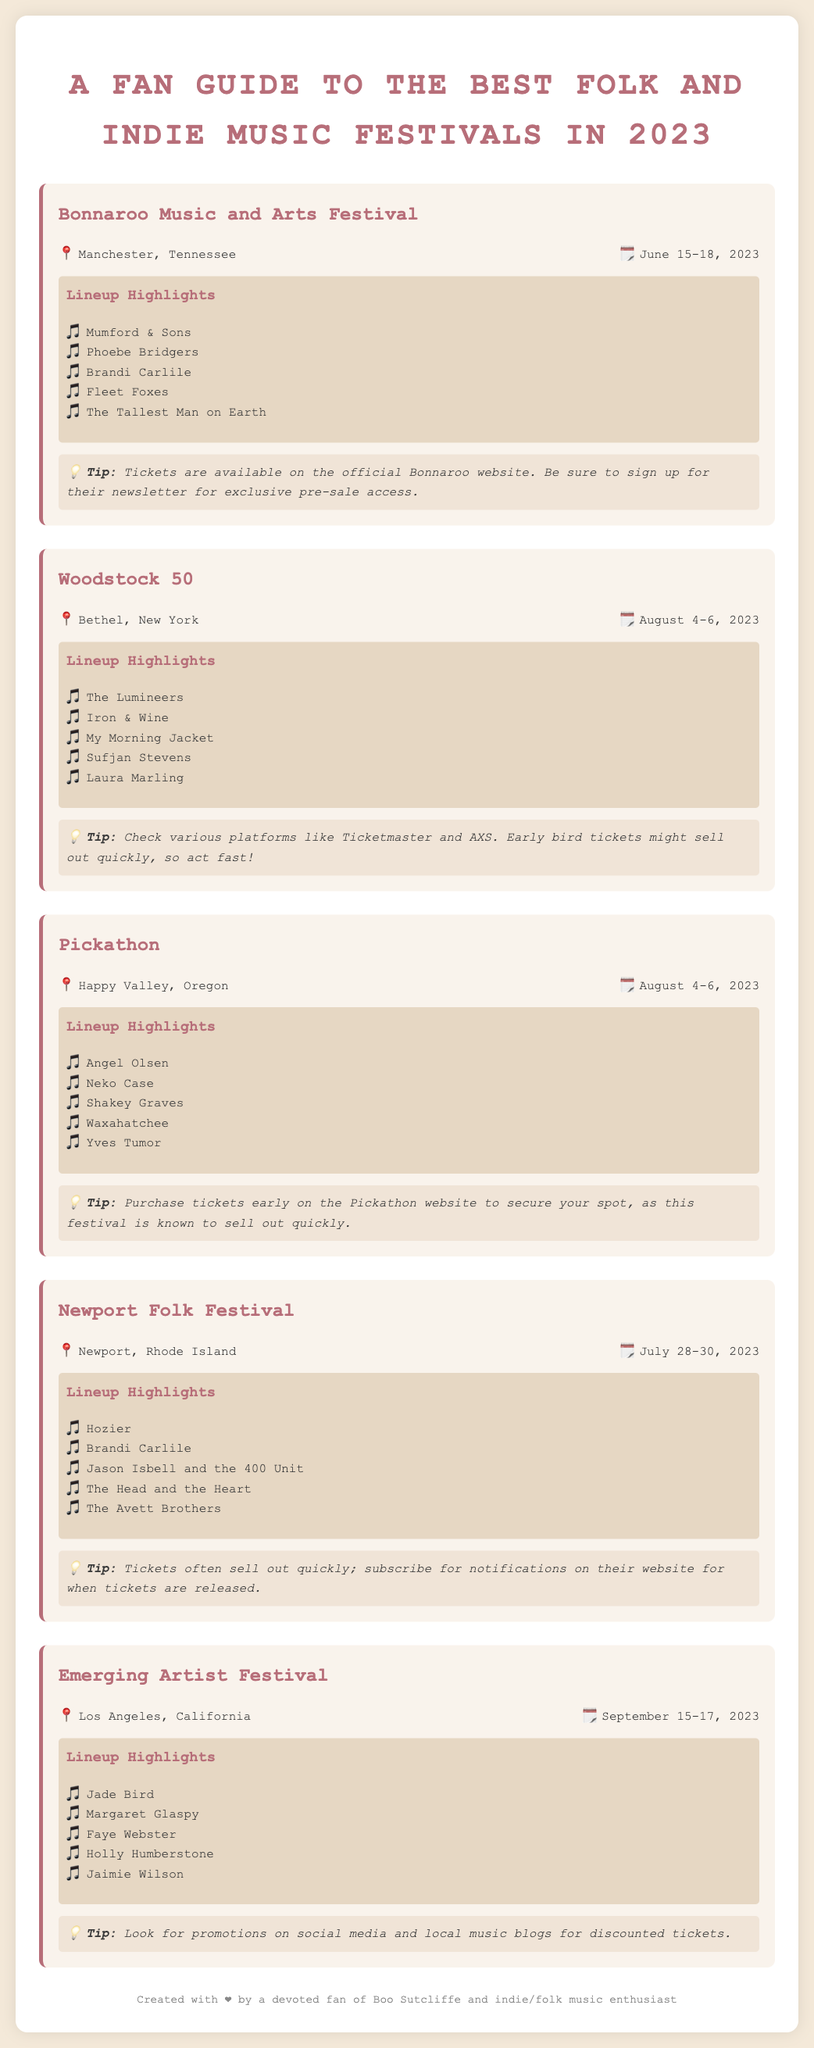What are the dates for the Bonnaroo Music and Arts Festival? The document lists the dates for Bonnaroo Music and Arts Festival as June 15-18, 2023.
Answer: June 15-18, 2023 Who are the lineup highlights for the Newport Folk Festival? The lineup highlights for the Newport Folk Festival are listed in the document.
Answer: Hozier, Brandi Carlile, Jason Isbell and the 400 Unit, The Head and the Heart, The Avett Brothers Where is the Pickathon festival held? The location of the Pickathon festival is mentioned in the document as Happy Valley, Oregon.
Answer: Happy Valley, Oregon What should attendees do to get tickets for the Emerging Artist Festival? The tips for the Emerging Artist Festival suggest looking for promotions for discounted tickets.
Answer: Look for promotions on social media and local music blogs Which festival occurs in August? The document outlines multiple festivals in August, including Woodstock 50 and Pickathon.
Answer: Woodstock 50, Pickathon How many days does the Newport Folk Festival last? The document states that the Newport Folk Festival lasts from July 28 to July 30, indicating it is three days long.
Answer: Three days What is a tip for purchasing tickets for Bonnaroo Music and Arts Festival? The document mentions signing up for the newsletter for exclusive pre-sale access as a ticket purchasing tip for Bonnaroo.
Answer: Sign up for their newsletter for exclusive pre-sale access 